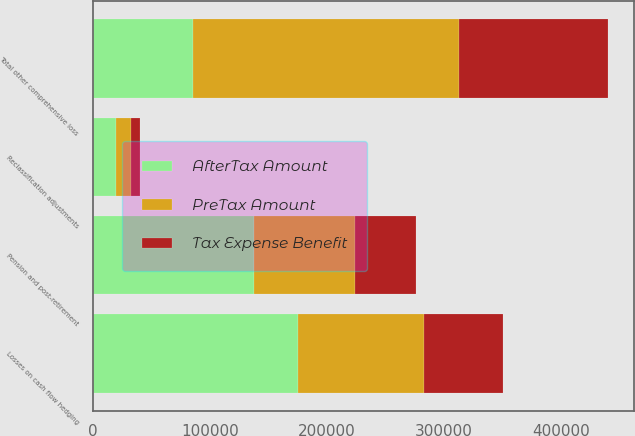Convert chart to OTSL. <chart><loc_0><loc_0><loc_500><loc_500><stacked_bar_chart><ecel><fcel>Pension and post-retirement<fcel>Losses on cash flow hedging<fcel>Reclassification adjustments<fcel>Total other comprehensive loss<nl><fcel>AfterTax Amount<fcel>137918<fcel>175011<fcel>20282<fcel>85823<nl><fcel>Tax Expense Benefit<fcel>52095<fcel>67298<fcel>7767<fcel>127160<nl><fcel>PreTax Amount<fcel>85823<fcel>107713<fcel>12515<fcel>227264<nl></chart> 